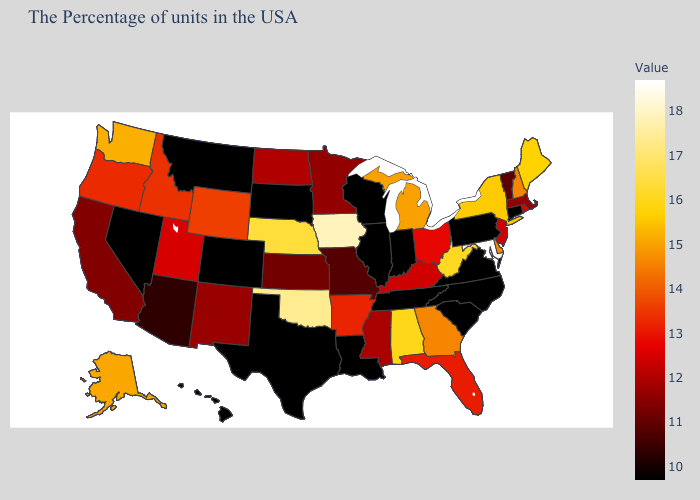Does Delaware have the lowest value in the South?
Short answer required. No. Does New York have a lower value than Maryland?
Short answer required. Yes. Which states have the lowest value in the Northeast?
Be succinct. Connecticut, Pennsylvania. Does California have the lowest value in the West?
Be succinct. No. Does Pennsylvania have the highest value in the Northeast?
Be succinct. No. Does Indiana have the lowest value in the USA?
Concise answer only. Yes. 